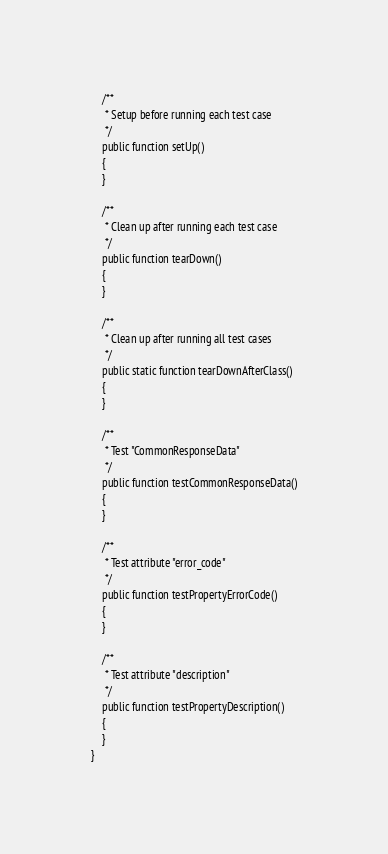<code> <loc_0><loc_0><loc_500><loc_500><_PHP_>
    /**
     * Setup before running each test case
     */
    public function setUp()
    {
    }

    /**
     * Clean up after running each test case
     */
    public function tearDown()
    {
    }

    /**
     * Clean up after running all test cases
     */
    public static function tearDownAfterClass()
    {
    }

    /**
     * Test "CommonResponseData"
     */
    public function testCommonResponseData()
    {
    }

    /**
     * Test attribute "error_code"
     */
    public function testPropertyErrorCode()
    {
    }

    /**
     * Test attribute "description"
     */
    public function testPropertyDescription()
    {
    }
}
</code> 